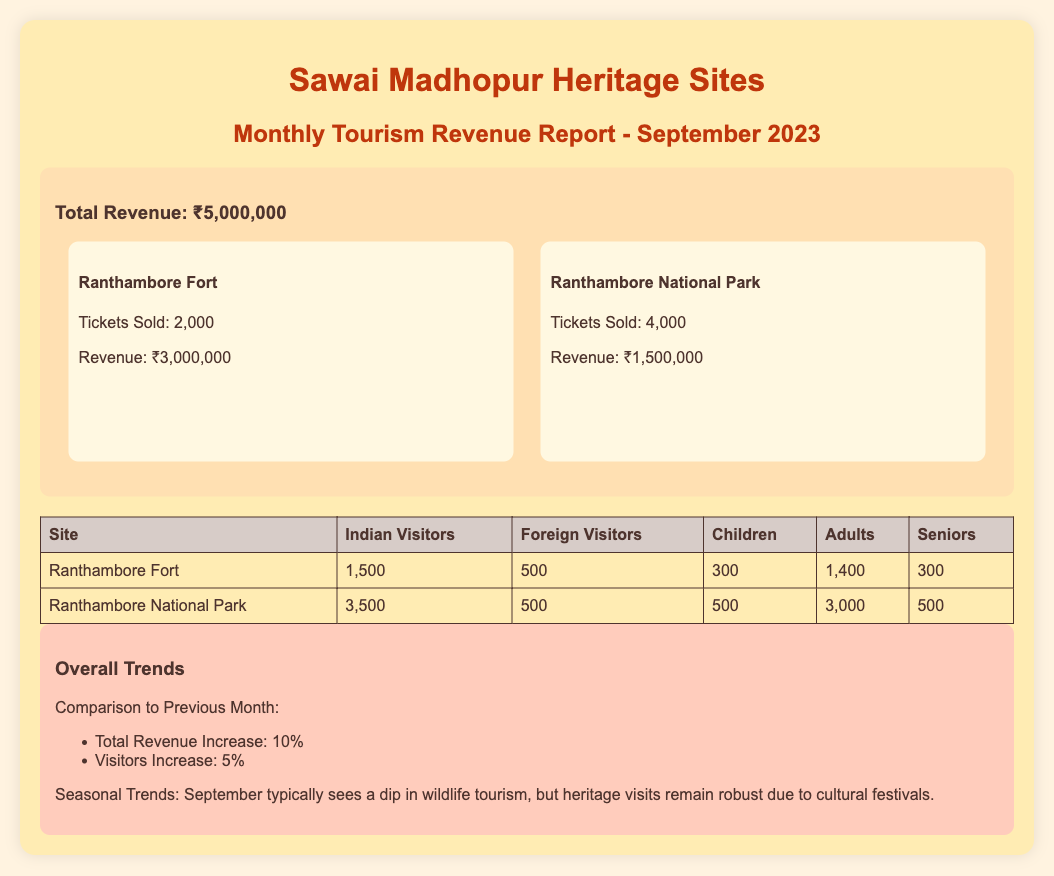what is the total revenue? The total revenue is provided at the top of the report and includes all ticket sales from different sites.
Answer: ₹5,000,000 how many tickets were sold for Ranthambore Fort? The document lists the number of tickets sold specifically for Ranthambore Fort.
Answer: 2,000 how many foreign visitors attended Ranthambore National Park? This information is provided in the visitor demographics section, specifying the foreign visitors for that site.
Answer: 500 what was the percentage increase in total revenue compared to the previous month? The trends section highlights the change in revenue from the previous month.
Answer: 10% how many Indian visitors visited Ranthambore Fort? The document specifies the number of Indian visitors for Ranthambore Fort in the table.
Answer: 1,500 what is the total number of adults who visited Ranthambore National Park? This data is given in the visitor demographics and specifies adults for that site.
Answer: 3,000 what seasonal trend is observed in September according to the report? The trends section mentions the usual pattern of tourism during this month concerning wildlife and heritage visits.
Answer: Dip in wildlife tourism which site generated the most revenue? The revenue for each site is specified, indicating which site brought in the highest total revenue.
Answer: Ranthambore Fort how many children visited Ranthambore National Park? The visitor demographics table provides the number of children for each site.
Answer: 500 